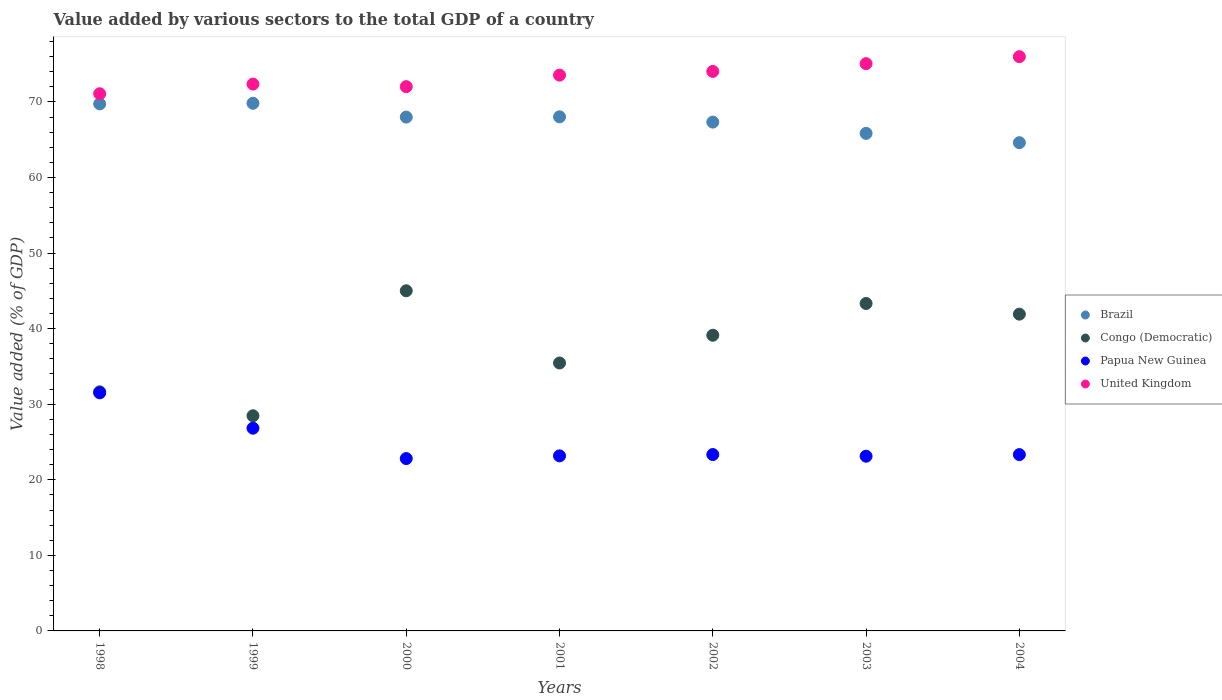How many different coloured dotlines are there?
Your answer should be compact. 4. What is the value added by various sectors to the total GDP in Congo (Democratic) in 1998?
Your response must be concise. 31.64. Across all years, what is the maximum value added by various sectors to the total GDP in Papua New Guinea?
Give a very brief answer. 31.51. Across all years, what is the minimum value added by various sectors to the total GDP in Congo (Democratic)?
Ensure brevity in your answer.  28.47. In which year was the value added by various sectors to the total GDP in United Kingdom maximum?
Give a very brief answer. 2004. In which year was the value added by various sectors to the total GDP in Brazil minimum?
Offer a very short reply. 2004. What is the total value added by various sectors to the total GDP in Brazil in the graph?
Your answer should be compact. 473.39. What is the difference between the value added by various sectors to the total GDP in United Kingdom in 1998 and that in 2002?
Ensure brevity in your answer.  -2.95. What is the difference between the value added by various sectors to the total GDP in Brazil in 2003 and the value added by various sectors to the total GDP in United Kingdom in 2000?
Provide a short and direct response. -6.18. What is the average value added by various sectors to the total GDP in Papua New Guinea per year?
Ensure brevity in your answer.  24.87. In the year 2003, what is the difference between the value added by various sectors to the total GDP in Congo (Democratic) and value added by various sectors to the total GDP in Papua New Guinea?
Keep it short and to the point. 20.21. In how many years, is the value added by various sectors to the total GDP in United Kingdom greater than 60 %?
Make the answer very short. 7. What is the ratio of the value added by various sectors to the total GDP in Congo (Democratic) in 2000 to that in 2004?
Provide a succinct answer. 1.07. Is the value added by various sectors to the total GDP in United Kingdom in 1999 less than that in 2000?
Offer a terse response. No. Is the difference between the value added by various sectors to the total GDP in Congo (Democratic) in 1999 and 2003 greater than the difference between the value added by various sectors to the total GDP in Papua New Guinea in 1999 and 2003?
Your answer should be very brief. No. What is the difference between the highest and the second highest value added by various sectors to the total GDP in Congo (Democratic)?
Give a very brief answer. 1.68. What is the difference between the highest and the lowest value added by various sectors to the total GDP in United Kingdom?
Your answer should be very brief. 4.9. In how many years, is the value added by various sectors to the total GDP in Papua New Guinea greater than the average value added by various sectors to the total GDP in Papua New Guinea taken over all years?
Ensure brevity in your answer.  2. Does the value added by various sectors to the total GDP in Brazil monotonically increase over the years?
Your answer should be very brief. No. How many dotlines are there?
Make the answer very short. 4. What is the difference between two consecutive major ticks on the Y-axis?
Keep it short and to the point. 10. Are the values on the major ticks of Y-axis written in scientific E-notation?
Provide a short and direct response. No. Does the graph contain grids?
Keep it short and to the point. No. What is the title of the graph?
Offer a terse response. Value added by various sectors to the total GDP of a country. What is the label or title of the Y-axis?
Ensure brevity in your answer.  Value added (% of GDP). What is the Value added (% of GDP) of Brazil in 1998?
Your answer should be compact. 69.75. What is the Value added (% of GDP) of Congo (Democratic) in 1998?
Your answer should be very brief. 31.64. What is the Value added (% of GDP) in Papua New Guinea in 1998?
Ensure brevity in your answer.  31.51. What is the Value added (% of GDP) of United Kingdom in 1998?
Provide a succinct answer. 71.09. What is the Value added (% of GDP) of Brazil in 1999?
Give a very brief answer. 69.83. What is the Value added (% of GDP) of Congo (Democratic) in 1999?
Provide a short and direct response. 28.47. What is the Value added (% of GDP) in Papua New Guinea in 1999?
Your response must be concise. 26.83. What is the Value added (% of GDP) of United Kingdom in 1999?
Keep it short and to the point. 72.37. What is the Value added (% of GDP) in Brazil in 2000?
Provide a short and direct response. 68. What is the Value added (% of GDP) in Congo (Democratic) in 2000?
Provide a short and direct response. 45.01. What is the Value added (% of GDP) in Papua New Guinea in 2000?
Your answer should be compact. 22.81. What is the Value added (% of GDP) in United Kingdom in 2000?
Your answer should be very brief. 72.03. What is the Value added (% of GDP) of Brazil in 2001?
Your answer should be compact. 68.03. What is the Value added (% of GDP) in Congo (Democratic) in 2001?
Provide a short and direct response. 35.46. What is the Value added (% of GDP) in Papua New Guinea in 2001?
Provide a succinct answer. 23.17. What is the Value added (% of GDP) of United Kingdom in 2001?
Your response must be concise. 73.55. What is the Value added (% of GDP) in Brazil in 2002?
Offer a terse response. 67.33. What is the Value added (% of GDP) in Congo (Democratic) in 2002?
Make the answer very short. 39.13. What is the Value added (% of GDP) in Papua New Guinea in 2002?
Give a very brief answer. 23.34. What is the Value added (% of GDP) of United Kingdom in 2002?
Give a very brief answer. 74.04. What is the Value added (% of GDP) in Brazil in 2003?
Provide a succinct answer. 65.84. What is the Value added (% of GDP) in Congo (Democratic) in 2003?
Your answer should be very brief. 43.33. What is the Value added (% of GDP) of Papua New Guinea in 2003?
Provide a short and direct response. 23.12. What is the Value added (% of GDP) in United Kingdom in 2003?
Your answer should be very brief. 75.07. What is the Value added (% of GDP) in Brazil in 2004?
Offer a terse response. 64.61. What is the Value added (% of GDP) of Congo (Democratic) in 2004?
Ensure brevity in your answer.  41.92. What is the Value added (% of GDP) of Papua New Guinea in 2004?
Keep it short and to the point. 23.33. What is the Value added (% of GDP) in United Kingdom in 2004?
Give a very brief answer. 75.99. Across all years, what is the maximum Value added (% of GDP) of Brazil?
Keep it short and to the point. 69.83. Across all years, what is the maximum Value added (% of GDP) in Congo (Democratic)?
Your response must be concise. 45.01. Across all years, what is the maximum Value added (% of GDP) of Papua New Guinea?
Ensure brevity in your answer.  31.51. Across all years, what is the maximum Value added (% of GDP) in United Kingdom?
Your answer should be very brief. 75.99. Across all years, what is the minimum Value added (% of GDP) in Brazil?
Your response must be concise. 64.61. Across all years, what is the minimum Value added (% of GDP) of Congo (Democratic)?
Ensure brevity in your answer.  28.47. Across all years, what is the minimum Value added (% of GDP) of Papua New Guinea?
Your answer should be compact. 22.81. Across all years, what is the minimum Value added (% of GDP) of United Kingdom?
Your answer should be compact. 71.09. What is the total Value added (% of GDP) in Brazil in the graph?
Offer a terse response. 473.39. What is the total Value added (% of GDP) in Congo (Democratic) in the graph?
Ensure brevity in your answer.  264.96. What is the total Value added (% of GDP) in Papua New Guinea in the graph?
Provide a short and direct response. 174.11. What is the total Value added (% of GDP) of United Kingdom in the graph?
Your response must be concise. 514.14. What is the difference between the Value added (% of GDP) in Brazil in 1998 and that in 1999?
Ensure brevity in your answer.  -0.08. What is the difference between the Value added (% of GDP) of Congo (Democratic) in 1998 and that in 1999?
Offer a very short reply. 3.17. What is the difference between the Value added (% of GDP) in Papua New Guinea in 1998 and that in 1999?
Your answer should be very brief. 4.68. What is the difference between the Value added (% of GDP) of United Kingdom in 1998 and that in 1999?
Ensure brevity in your answer.  -1.28. What is the difference between the Value added (% of GDP) of Brazil in 1998 and that in 2000?
Offer a terse response. 1.75. What is the difference between the Value added (% of GDP) in Congo (Democratic) in 1998 and that in 2000?
Your answer should be compact. -13.37. What is the difference between the Value added (% of GDP) of Papua New Guinea in 1998 and that in 2000?
Offer a very short reply. 8.7. What is the difference between the Value added (% of GDP) of United Kingdom in 1998 and that in 2000?
Give a very brief answer. -0.94. What is the difference between the Value added (% of GDP) of Brazil in 1998 and that in 2001?
Your answer should be very brief. 1.71. What is the difference between the Value added (% of GDP) of Congo (Democratic) in 1998 and that in 2001?
Offer a very short reply. -3.81. What is the difference between the Value added (% of GDP) in Papua New Guinea in 1998 and that in 2001?
Provide a short and direct response. 8.34. What is the difference between the Value added (% of GDP) in United Kingdom in 1998 and that in 2001?
Your answer should be very brief. -2.46. What is the difference between the Value added (% of GDP) of Brazil in 1998 and that in 2002?
Keep it short and to the point. 2.41. What is the difference between the Value added (% of GDP) of Congo (Democratic) in 1998 and that in 2002?
Your answer should be very brief. -7.49. What is the difference between the Value added (% of GDP) in Papua New Guinea in 1998 and that in 2002?
Give a very brief answer. 8.17. What is the difference between the Value added (% of GDP) of United Kingdom in 1998 and that in 2002?
Ensure brevity in your answer.  -2.95. What is the difference between the Value added (% of GDP) in Brazil in 1998 and that in 2003?
Your response must be concise. 3.9. What is the difference between the Value added (% of GDP) in Congo (Democratic) in 1998 and that in 2003?
Keep it short and to the point. -11.69. What is the difference between the Value added (% of GDP) in Papua New Guinea in 1998 and that in 2003?
Your answer should be compact. 8.39. What is the difference between the Value added (% of GDP) in United Kingdom in 1998 and that in 2003?
Ensure brevity in your answer.  -3.98. What is the difference between the Value added (% of GDP) in Brazil in 1998 and that in 2004?
Provide a short and direct response. 5.13. What is the difference between the Value added (% of GDP) of Congo (Democratic) in 1998 and that in 2004?
Make the answer very short. -10.28. What is the difference between the Value added (% of GDP) in Papua New Guinea in 1998 and that in 2004?
Your answer should be compact. 8.18. What is the difference between the Value added (% of GDP) in United Kingdom in 1998 and that in 2004?
Ensure brevity in your answer.  -4.9. What is the difference between the Value added (% of GDP) in Brazil in 1999 and that in 2000?
Your answer should be very brief. 1.83. What is the difference between the Value added (% of GDP) of Congo (Democratic) in 1999 and that in 2000?
Your answer should be compact. -16.54. What is the difference between the Value added (% of GDP) of Papua New Guinea in 1999 and that in 2000?
Offer a terse response. 4.02. What is the difference between the Value added (% of GDP) in United Kingdom in 1999 and that in 2000?
Provide a succinct answer. 0.34. What is the difference between the Value added (% of GDP) in Brazil in 1999 and that in 2001?
Offer a terse response. 1.79. What is the difference between the Value added (% of GDP) in Congo (Democratic) in 1999 and that in 2001?
Make the answer very short. -6.98. What is the difference between the Value added (% of GDP) in Papua New Guinea in 1999 and that in 2001?
Make the answer very short. 3.66. What is the difference between the Value added (% of GDP) in United Kingdom in 1999 and that in 2001?
Your answer should be very brief. -1.19. What is the difference between the Value added (% of GDP) in Brazil in 1999 and that in 2002?
Offer a terse response. 2.49. What is the difference between the Value added (% of GDP) of Congo (Democratic) in 1999 and that in 2002?
Give a very brief answer. -10.65. What is the difference between the Value added (% of GDP) of Papua New Guinea in 1999 and that in 2002?
Your response must be concise. 3.49. What is the difference between the Value added (% of GDP) in United Kingdom in 1999 and that in 2002?
Offer a terse response. -1.67. What is the difference between the Value added (% of GDP) of Brazil in 1999 and that in 2003?
Give a very brief answer. 3.98. What is the difference between the Value added (% of GDP) of Congo (Democratic) in 1999 and that in 2003?
Ensure brevity in your answer.  -14.86. What is the difference between the Value added (% of GDP) of Papua New Guinea in 1999 and that in 2003?
Your answer should be very brief. 3.71. What is the difference between the Value added (% of GDP) of United Kingdom in 1999 and that in 2003?
Provide a succinct answer. -2.7. What is the difference between the Value added (% of GDP) in Brazil in 1999 and that in 2004?
Provide a short and direct response. 5.22. What is the difference between the Value added (% of GDP) in Congo (Democratic) in 1999 and that in 2004?
Your response must be concise. -13.45. What is the difference between the Value added (% of GDP) of Papua New Guinea in 1999 and that in 2004?
Offer a terse response. 3.5. What is the difference between the Value added (% of GDP) in United Kingdom in 1999 and that in 2004?
Your answer should be very brief. -3.63. What is the difference between the Value added (% of GDP) in Brazil in 2000 and that in 2001?
Offer a terse response. -0.04. What is the difference between the Value added (% of GDP) of Congo (Democratic) in 2000 and that in 2001?
Keep it short and to the point. 9.56. What is the difference between the Value added (% of GDP) in Papua New Guinea in 2000 and that in 2001?
Provide a succinct answer. -0.36. What is the difference between the Value added (% of GDP) in United Kingdom in 2000 and that in 2001?
Ensure brevity in your answer.  -1.53. What is the difference between the Value added (% of GDP) in Brazil in 2000 and that in 2002?
Provide a succinct answer. 0.66. What is the difference between the Value added (% of GDP) in Congo (Democratic) in 2000 and that in 2002?
Provide a succinct answer. 5.89. What is the difference between the Value added (% of GDP) of Papua New Guinea in 2000 and that in 2002?
Give a very brief answer. -0.53. What is the difference between the Value added (% of GDP) of United Kingdom in 2000 and that in 2002?
Your response must be concise. -2.01. What is the difference between the Value added (% of GDP) in Brazil in 2000 and that in 2003?
Keep it short and to the point. 2.15. What is the difference between the Value added (% of GDP) of Congo (Democratic) in 2000 and that in 2003?
Your answer should be compact. 1.68. What is the difference between the Value added (% of GDP) in Papua New Guinea in 2000 and that in 2003?
Ensure brevity in your answer.  -0.31. What is the difference between the Value added (% of GDP) in United Kingdom in 2000 and that in 2003?
Ensure brevity in your answer.  -3.04. What is the difference between the Value added (% of GDP) in Brazil in 2000 and that in 2004?
Offer a terse response. 3.39. What is the difference between the Value added (% of GDP) of Congo (Democratic) in 2000 and that in 2004?
Offer a very short reply. 3.09. What is the difference between the Value added (% of GDP) in Papua New Guinea in 2000 and that in 2004?
Give a very brief answer. -0.53. What is the difference between the Value added (% of GDP) in United Kingdom in 2000 and that in 2004?
Provide a short and direct response. -3.97. What is the difference between the Value added (% of GDP) in Brazil in 2001 and that in 2002?
Offer a terse response. 0.7. What is the difference between the Value added (% of GDP) in Congo (Democratic) in 2001 and that in 2002?
Keep it short and to the point. -3.67. What is the difference between the Value added (% of GDP) in Papua New Guinea in 2001 and that in 2002?
Your answer should be compact. -0.17. What is the difference between the Value added (% of GDP) in United Kingdom in 2001 and that in 2002?
Offer a very short reply. -0.49. What is the difference between the Value added (% of GDP) in Brazil in 2001 and that in 2003?
Offer a terse response. 2.19. What is the difference between the Value added (% of GDP) of Congo (Democratic) in 2001 and that in 2003?
Provide a succinct answer. -7.88. What is the difference between the Value added (% of GDP) of Papua New Guinea in 2001 and that in 2003?
Make the answer very short. 0.05. What is the difference between the Value added (% of GDP) of United Kingdom in 2001 and that in 2003?
Provide a short and direct response. -1.52. What is the difference between the Value added (% of GDP) of Brazil in 2001 and that in 2004?
Ensure brevity in your answer.  3.42. What is the difference between the Value added (% of GDP) of Congo (Democratic) in 2001 and that in 2004?
Offer a very short reply. -6.46. What is the difference between the Value added (% of GDP) of Papua New Guinea in 2001 and that in 2004?
Give a very brief answer. -0.17. What is the difference between the Value added (% of GDP) of United Kingdom in 2001 and that in 2004?
Provide a short and direct response. -2.44. What is the difference between the Value added (% of GDP) of Brazil in 2002 and that in 2003?
Provide a short and direct response. 1.49. What is the difference between the Value added (% of GDP) in Congo (Democratic) in 2002 and that in 2003?
Provide a short and direct response. -4.21. What is the difference between the Value added (% of GDP) of Papua New Guinea in 2002 and that in 2003?
Your answer should be compact. 0.22. What is the difference between the Value added (% of GDP) of United Kingdom in 2002 and that in 2003?
Provide a short and direct response. -1.03. What is the difference between the Value added (% of GDP) in Brazil in 2002 and that in 2004?
Provide a short and direct response. 2.72. What is the difference between the Value added (% of GDP) of Congo (Democratic) in 2002 and that in 2004?
Offer a very short reply. -2.79. What is the difference between the Value added (% of GDP) of Papua New Guinea in 2002 and that in 2004?
Offer a very short reply. 0.01. What is the difference between the Value added (% of GDP) in United Kingdom in 2002 and that in 2004?
Offer a terse response. -1.95. What is the difference between the Value added (% of GDP) of Brazil in 2003 and that in 2004?
Ensure brevity in your answer.  1.23. What is the difference between the Value added (% of GDP) in Congo (Democratic) in 2003 and that in 2004?
Your response must be concise. 1.41. What is the difference between the Value added (% of GDP) in Papua New Guinea in 2003 and that in 2004?
Ensure brevity in your answer.  -0.21. What is the difference between the Value added (% of GDP) of United Kingdom in 2003 and that in 2004?
Offer a very short reply. -0.92. What is the difference between the Value added (% of GDP) in Brazil in 1998 and the Value added (% of GDP) in Congo (Democratic) in 1999?
Your response must be concise. 41.27. What is the difference between the Value added (% of GDP) of Brazil in 1998 and the Value added (% of GDP) of Papua New Guinea in 1999?
Your answer should be compact. 42.92. What is the difference between the Value added (% of GDP) in Brazil in 1998 and the Value added (% of GDP) in United Kingdom in 1999?
Provide a short and direct response. -2.62. What is the difference between the Value added (% of GDP) of Congo (Democratic) in 1998 and the Value added (% of GDP) of Papua New Guinea in 1999?
Provide a succinct answer. 4.81. What is the difference between the Value added (% of GDP) in Congo (Democratic) in 1998 and the Value added (% of GDP) in United Kingdom in 1999?
Provide a short and direct response. -40.73. What is the difference between the Value added (% of GDP) in Papua New Guinea in 1998 and the Value added (% of GDP) in United Kingdom in 1999?
Make the answer very short. -40.86. What is the difference between the Value added (% of GDP) of Brazil in 1998 and the Value added (% of GDP) of Congo (Democratic) in 2000?
Provide a succinct answer. 24.73. What is the difference between the Value added (% of GDP) of Brazil in 1998 and the Value added (% of GDP) of Papua New Guinea in 2000?
Your answer should be compact. 46.94. What is the difference between the Value added (% of GDP) in Brazil in 1998 and the Value added (% of GDP) in United Kingdom in 2000?
Your response must be concise. -2.28. What is the difference between the Value added (% of GDP) of Congo (Democratic) in 1998 and the Value added (% of GDP) of Papua New Guinea in 2000?
Give a very brief answer. 8.83. What is the difference between the Value added (% of GDP) of Congo (Democratic) in 1998 and the Value added (% of GDP) of United Kingdom in 2000?
Give a very brief answer. -40.39. What is the difference between the Value added (% of GDP) of Papua New Guinea in 1998 and the Value added (% of GDP) of United Kingdom in 2000?
Give a very brief answer. -40.52. What is the difference between the Value added (% of GDP) in Brazil in 1998 and the Value added (% of GDP) in Congo (Democratic) in 2001?
Provide a short and direct response. 34.29. What is the difference between the Value added (% of GDP) in Brazil in 1998 and the Value added (% of GDP) in Papua New Guinea in 2001?
Give a very brief answer. 46.58. What is the difference between the Value added (% of GDP) of Brazil in 1998 and the Value added (% of GDP) of United Kingdom in 2001?
Your response must be concise. -3.81. What is the difference between the Value added (% of GDP) in Congo (Democratic) in 1998 and the Value added (% of GDP) in Papua New Guinea in 2001?
Offer a very short reply. 8.47. What is the difference between the Value added (% of GDP) of Congo (Democratic) in 1998 and the Value added (% of GDP) of United Kingdom in 2001?
Your response must be concise. -41.91. What is the difference between the Value added (% of GDP) of Papua New Guinea in 1998 and the Value added (% of GDP) of United Kingdom in 2001?
Your answer should be very brief. -42.04. What is the difference between the Value added (% of GDP) in Brazil in 1998 and the Value added (% of GDP) in Congo (Democratic) in 2002?
Your answer should be very brief. 30.62. What is the difference between the Value added (% of GDP) of Brazil in 1998 and the Value added (% of GDP) of Papua New Guinea in 2002?
Give a very brief answer. 46.4. What is the difference between the Value added (% of GDP) in Brazil in 1998 and the Value added (% of GDP) in United Kingdom in 2002?
Your response must be concise. -4.29. What is the difference between the Value added (% of GDP) in Congo (Democratic) in 1998 and the Value added (% of GDP) in Papua New Guinea in 2002?
Provide a short and direct response. 8.3. What is the difference between the Value added (% of GDP) of Congo (Democratic) in 1998 and the Value added (% of GDP) of United Kingdom in 2002?
Ensure brevity in your answer.  -42.4. What is the difference between the Value added (% of GDP) in Papua New Guinea in 1998 and the Value added (% of GDP) in United Kingdom in 2002?
Your answer should be compact. -42.53. What is the difference between the Value added (% of GDP) in Brazil in 1998 and the Value added (% of GDP) in Congo (Democratic) in 2003?
Offer a very short reply. 26.41. What is the difference between the Value added (% of GDP) in Brazil in 1998 and the Value added (% of GDP) in Papua New Guinea in 2003?
Offer a very short reply. 46.63. What is the difference between the Value added (% of GDP) of Brazil in 1998 and the Value added (% of GDP) of United Kingdom in 2003?
Offer a terse response. -5.32. What is the difference between the Value added (% of GDP) in Congo (Democratic) in 1998 and the Value added (% of GDP) in Papua New Guinea in 2003?
Your response must be concise. 8.52. What is the difference between the Value added (% of GDP) in Congo (Democratic) in 1998 and the Value added (% of GDP) in United Kingdom in 2003?
Give a very brief answer. -43.43. What is the difference between the Value added (% of GDP) of Papua New Guinea in 1998 and the Value added (% of GDP) of United Kingdom in 2003?
Provide a short and direct response. -43.56. What is the difference between the Value added (% of GDP) in Brazil in 1998 and the Value added (% of GDP) in Congo (Democratic) in 2004?
Give a very brief answer. 27.83. What is the difference between the Value added (% of GDP) in Brazil in 1998 and the Value added (% of GDP) in Papua New Guinea in 2004?
Offer a terse response. 46.41. What is the difference between the Value added (% of GDP) in Brazil in 1998 and the Value added (% of GDP) in United Kingdom in 2004?
Provide a short and direct response. -6.25. What is the difference between the Value added (% of GDP) of Congo (Democratic) in 1998 and the Value added (% of GDP) of Papua New Guinea in 2004?
Offer a very short reply. 8.31. What is the difference between the Value added (% of GDP) of Congo (Democratic) in 1998 and the Value added (% of GDP) of United Kingdom in 2004?
Provide a short and direct response. -44.35. What is the difference between the Value added (% of GDP) of Papua New Guinea in 1998 and the Value added (% of GDP) of United Kingdom in 2004?
Offer a very short reply. -44.48. What is the difference between the Value added (% of GDP) of Brazil in 1999 and the Value added (% of GDP) of Congo (Democratic) in 2000?
Give a very brief answer. 24.81. What is the difference between the Value added (% of GDP) of Brazil in 1999 and the Value added (% of GDP) of Papua New Guinea in 2000?
Give a very brief answer. 47.02. What is the difference between the Value added (% of GDP) of Brazil in 1999 and the Value added (% of GDP) of United Kingdom in 2000?
Your answer should be compact. -2.2. What is the difference between the Value added (% of GDP) in Congo (Democratic) in 1999 and the Value added (% of GDP) in Papua New Guinea in 2000?
Your response must be concise. 5.66. What is the difference between the Value added (% of GDP) of Congo (Democratic) in 1999 and the Value added (% of GDP) of United Kingdom in 2000?
Provide a short and direct response. -43.55. What is the difference between the Value added (% of GDP) in Papua New Guinea in 1999 and the Value added (% of GDP) in United Kingdom in 2000?
Ensure brevity in your answer.  -45.2. What is the difference between the Value added (% of GDP) of Brazil in 1999 and the Value added (% of GDP) of Congo (Democratic) in 2001?
Your response must be concise. 34.37. What is the difference between the Value added (% of GDP) of Brazil in 1999 and the Value added (% of GDP) of Papua New Guinea in 2001?
Provide a short and direct response. 46.66. What is the difference between the Value added (% of GDP) of Brazil in 1999 and the Value added (% of GDP) of United Kingdom in 2001?
Give a very brief answer. -3.73. What is the difference between the Value added (% of GDP) in Congo (Democratic) in 1999 and the Value added (% of GDP) in Papua New Guinea in 2001?
Your answer should be very brief. 5.31. What is the difference between the Value added (% of GDP) in Congo (Democratic) in 1999 and the Value added (% of GDP) in United Kingdom in 2001?
Provide a short and direct response. -45.08. What is the difference between the Value added (% of GDP) of Papua New Guinea in 1999 and the Value added (% of GDP) of United Kingdom in 2001?
Ensure brevity in your answer.  -46.72. What is the difference between the Value added (% of GDP) in Brazil in 1999 and the Value added (% of GDP) in Congo (Democratic) in 2002?
Your response must be concise. 30.7. What is the difference between the Value added (% of GDP) in Brazil in 1999 and the Value added (% of GDP) in Papua New Guinea in 2002?
Your response must be concise. 46.48. What is the difference between the Value added (% of GDP) of Brazil in 1999 and the Value added (% of GDP) of United Kingdom in 2002?
Ensure brevity in your answer.  -4.21. What is the difference between the Value added (% of GDP) of Congo (Democratic) in 1999 and the Value added (% of GDP) of Papua New Guinea in 2002?
Your answer should be compact. 5.13. What is the difference between the Value added (% of GDP) of Congo (Democratic) in 1999 and the Value added (% of GDP) of United Kingdom in 2002?
Your answer should be compact. -45.57. What is the difference between the Value added (% of GDP) in Papua New Guinea in 1999 and the Value added (% of GDP) in United Kingdom in 2002?
Ensure brevity in your answer.  -47.21. What is the difference between the Value added (% of GDP) of Brazil in 1999 and the Value added (% of GDP) of Congo (Democratic) in 2003?
Provide a succinct answer. 26.49. What is the difference between the Value added (% of GDP) in Brazil in 1999 and the Value added (% of GDP) in Papua New Guinea in 2003?
Offer a very short reply. 46.71. What is the difference between the Value added (% of GDP) of Brazil in 1999 and the Value added (% of GDP) of United Kingdom in 2003?
Your answer should be compact. -5.24. What is the difference between the Value added (% of GDP) in Congo (Democratic) in 1999 and the Value added (% of GDP) in Papua New Guinea in 2003?
Provide a succinct answer. 5.35. What is the difference between the Value added (% of GDP) of Congo (Democratic) in 1999 and the Value added (% of GDP) of United Kingdom in 2003?
Ensure brevity in your answer.  -46.6. What is the difference between the Value added (% of GDP) of Papua New Guinea in 1999 and the Value added (% of GDP) of United Kingdom in 2003?
Keep it short and to the point. -48.24. What is the difference between the Value added (% of GDP) in Brazil in 1999 and the Value added (% of GDP) in Congo (Democratic) in 2004?
Offer a very short reply. 27.91. What is the difference between the Value added (% of GDP) of Brazil in 1999 and the Value added (% of GDP) of Papua New Guinea in 2004?
Provide a succinct answer. 46.49. What is the difference between the Value added (% of GDP) in Brazil in 1999 and the Value added (% of GDP) in United Kingdom in 2004?
Keep it short and to the point. -6.17. What is the difference between the Value added (% of GDP) of Congo (Democratic) in 1999 and the Value added (% of GDP) of Papua New Guinea in 2004?
Offer a very short reply. 5.14. What is the difference between the Value added (% of GDP) of Congo (Democratic) in 1999 and the Value added (% of GDP) of United Kingdom in 2004?
Offer a very short reply. -47.52. What is the difference between the Value added (% of GDP) in Papua New Guinea in 1999 and the Value added (% of GDP) in United Kingdom in 2004?
Ensure brevity in your answer.  -49.16. What is the difference between the Value added (% of GDP) of Brazil in 2000 and the Value added (% of GDP) of Congo (Democratic) in 2001?
Keep it short and to the point. 32.54. What is the difference between the Value added (% of GDP) in Brazil in 2000 and the Value added (% of GDP) in Papua New Guinea in 2001?
Ensure brevity in your answer.  44.83. What is the difference between the Value added (% of GDP) in Brazil in 2000 and the Value added (% of GDP) in United Kingdom in 2001?
Your answer should be compact. -5.56. What is the difference between the Value added (% of GDP) in Congo (Democratic) in 2000 and the Value added (% of GDP) in Papua New Guinea in 2001?
Provide a short and direct response. 21.85. What is the difference between the Value added (% of GDP) of Congo (Democratic) in 2000 and the Value added (% of GDP) of United Kingdom in 2001?
Offer a very short reply. -28.54. What is the difference between the Value added (% of GDP) of Papua New Guinea in 2000 and the Value added (% of GDP) of United Kingdom in 2001?
Give a very brief answer. -50.74. What is the difference between the Value added (% of GDP) in Brazil in 2000 and the Value added (% of GDP) in Congo (Democratic) in 2002?
Provide a succinct answer. 28.87. What is the difference between the Value added (% of GDP) in Brazil in 2000 and the Value added (% of GDP) in Papua New Guinea in 2002?
Keep it short and to the point. 44.66. What is the difference between the Value added (% of GDP) in Brazil in 2000 and the Value added (% of GDP) in United Kingdom in 2002?
Your answer should be very brief. -6.04. What is the difference between the Value added (% of GDP) of Congo (Democratic) in 2000 and the Value added (% of GDP) of Papua New Guinea in 2002?
Keep it short and to the point. 21.67. What is the difference between the Value added (% of GDP) of Congo (Democratic) in 2000 and the Value added (% of GDP) of United Kingdom in 2002?
Offer a terse response. -29.03. What is the difference between the Value added (% of GDP) of Papua New Guinea in 2000 and the Value added (% of GDP) of United Kingdom in 2002?
Offer a terse response. -51.23. What is the difference between the Value added (% of GDP) of Brazil in 2000 and the Value added (% of GDP) of Congo (Democratic) in 2003?
Keep it short and to the point. 24.66. What is the difference between the Value added (% of GDP) of Brazil in 2000 and the Value added (% of GDP) of Papua New Guinea in 2003?
Make the answer very short. 44.88. What is the difference between the Value added (% of GDP) of Brazil in 2000 and the Value added (% of GDP) of United Kingdom in 2003?
Offer a terse response. -7.07. What is the difference between the Value added (% of GDP) of Congo (Democratic) in 2000 and the Value added (% of GDP) of Papua New Guinea in 2003?
Make the answer very short. 21.89. What is the difference between the Value added (% of GDP) in Congo (Democratic) in 2000 and the Value added (% of GDP) in United Kingdom in 2003?
Your answer should be compact. -30.06. What is the difference between the Value added (% of GDP) in Papua New Guinea in 2000 and the Value added (% of GDP) in United Kingdom in 2003?
Provide a succinct answer. -52.26. What is the difference between the Value added (% of GDP) of Brazil in 2000 and the Value added (% of GDP) of Congo (Democratic) in 2004?
Keep it short and to the point. 26.08. What is the difference between the Value added (% of GDP) of Brazil in 2000 and the Value added (% of GDP) of Papua New Guinea in 2004?
Your response must be concise. 44.66. What is the difference between the Value added (% of GDP) in Brazil in 2000 and the Value added (% of GDP) in United Kingdom in 2004?
Ensure brevity in your answer.  -8. What is the difference between the Value added (% of GDP) of Congo (Democratic) in 2000 and the Value added (% of GDP) of Papua New Guinea in 2004?
Keep it short and to the point. 21.68. What is the difference between the Value added (% of GDP) of Congo (Democratic) in 2000 and the Value added (% of GDP) of United Kingdom in 2004?
Your response must be concise. -30.98. What is the difference between the Value added (% of GDP) in Papua New Guinea in 2000 and the Value added (% of GDP) in United Kingdom in 2004?
Ensure brevity in your answer.  -53.18. What is the difference between the Value added (% of GDP) in Brazil in 2001 and the Value added (% of GDP) in Congo (Democratic) in 2002?
Make the answer very short. 28.91. What is the difference between the Value added (% of GDP) of Brazil in 2001 and the Value added (% of GDP) of Papua New Guinea in 2002?
Make the answer very short. 44.69. What is the difference between the Value added (% of GDP) in Brazil in 2001 and the Value added (% of GDP) in United Kingdom in 2002?
Keep it short and to the point. -6.01. What is the difference between the Value added (% of GDP) in Congo (Democratic) in 2001 and the Value added (% of GDP) in Papua New Guinea in 2002?
Provide a succinct answer. 12.11. What is the difference between the Value added (% of GDP) of Congo (Democratic) in 2001 and the Value added (% of GDP) of United Kingdom in 2002?
Provide a succinct answer. -38.58. What is the difference between the Value added (% of GDP) of Papua New Guinea in 2001 and the Value added (% of GDP) of United Kingdom in 2002?
Make the answer very short. -50.87. What is the difference between the Value added (% of GDP) in Brazil in 2001 and the Value added (% of GDP) in Congo (Democratic) in 2003?
Ensure brevity in your answer.  24.7. What is the difference between the Value added (% of GDP) of Brazil in 2001 and the Value added (% of GDP) of Papua New Guinea in 2003?
Your response must be concise. 44.91. What is the difference between the Value added (% of GDP) of Brazil in 2001 and the Value added (% of GDP) of United Kingdom in 2003?
Provide a succinct answer. -7.04. What is the difference between the Value added (% of GDP) of Congo (Democratic) in 2001 and the Value added (% of GDP) of Papua New Guinea in 2003?
Provide a short and direct response. 12.34. What is the difference between the Value added (% of GDP) in Congo (Democratic) in 2001 and the Value added (% of GDP) in United Kingdom in 2003?
Offer a very short reply. -39.61. What is the difference between the Value added (% of GDP) of Papua New Guinea in 2001 and the Value added (% of GDP) of United Kingdom in 2003?
Ensure brevity in your answer.  -51.9. What is the difference between the Value added (% of GDP) in Brazil in 2001 and the Value added (% of GDP) in Congo (Democratic) in 2004?
Make the answer very short. 26.11. What is the difference between the Value added (% of GDP) of Brazil in 2001 and the Value added (% of GDP) of Papua New Guinea in 2004?
Give a very brief answer. 44.7. What is the difference between the Value added (% of GDP) of Brazil in 2001 and the Value added (% of GDP) of United Kingdom in 2004?
Ensure brevity in your answer.  -7.96. What is the difference between the Value added (% of GDP) of Congo (Democratic) in 2001 and the Value added (% of GDP) of Papua New Guinea in 2004?
Provide a succinct answer. 12.12. What is the difference between the Value added (% of GDP) in Congo (Democratic) in 2001 and the Value added (% of GDP) in United Kingdom in 2004?
Provide a short and direct response. -40.54. What is the difference between the Value added (% of GDP) of Papua New Guinea in 2001 and the Value added (% of GDP) of United Kingdom in 2004?
Give a very brief answer. -52.83. What is the difference between the Value added (% of GDP) in Brazil in 2002 and the Value added (% of GDP) in Congo (Democratic) in 2003?
Make the answer very short. 24. What is the difference between the Value added (% of GDP) in Brazil in 2002 and the Value added (% of GDP) in Papua New Guinea in 2003?
Make the answer very short. 44.21. What is the difference between the Value added (% of GDP) in Brazil in 2002 and the Value added (% of GDP) in United Kingdom in 2003?
Provide a succinct answer. -7.74. What is the difference between the Value added (% of GDP) of Congo (Democratic) in 2002 and the Value added (% of GDP) of Papua New Guinea in 2003?
Offer a terse response. 16.01. What is the difference between the Value added (% of GDP) in Congo (Democratic) in 2002 and the Value added (% of GDP) in United Kingdom in 2003?
Your answer should be very brief. -35.94. What is the difference between the Value added (% of GDP) of Papua New Guinea in 2002 and the Value added (% of GDP) of United Kingdom in 2003?
Keep it short and to the point. -51.73. What is the difference between the Value added (% of GDP) of Brazil in 2002 and the Value added (% of GDP) of Congo (Democratic) in 2004?
Offer a very short reply. 25.41. What is the difference between the Value added (% of GDP) of Brazil in 2002 and the Value added (% of GDP) of Papua New Guinea in 2004?
Offer a very short reply. 44. What is the difference between the Value added (% of GDP) of Brazil in 2002 and the Value added (% of GDP) of United Kingdom in 2004?
Provide a short and direct response. -8.66. What is the difference between the Value added (% of GDP) in Congo (Democratic) in 2002 and the Value added (% of GDP) in Papua New Guinea in 2004?
Your response must be concise. 15.79. What is the difference between the Value added (% of GDP) in Congo (Democratic) in 2002 and the Value added (% of GDP) in United Kingdom in 2004?
Provide a succinct answer. -36.87. What is the difference between the Value added (% of GDP) in Papua New Guinea in 2002 and the Value added (% of GDP) in United Kingdom in 2004?
Provide a short and direct response. -52.65. What is the difference between the Value added (% of GDP) of Brazil in 2003 and the Value added (% of GDP) of Congo (Democratic) in 2004?
Offer a terse response. 23.93. What is the difference between the Value added (% of GDP) of Brazil in 2003 and the Value added (% of GDP) of Papua New Guinea in 2004?
Give a very brief answer. 42.51. What is the difference between the Value added (% of GDP) in Brazil in 2003 and the Value added (% of GDP) in United Kingdom in 2004?
Give a very brief answer. -10.15. What is the difference between the Value added (% of GDP) of Congo (Democratic) in 2003 and the Value added (% of GDP) of Papua New Guinea in 2004?
Offer a very short reply. 20. What is the difference between the Value added (% of GDP) of Congo (Democratic) in 2003 and the Value added (% of GDP) of United Kingdom in 2004?
Give a very brief answer. -32.66. What is the difference between the Value added (% of GDP) in Papua New Guinea in 2003 and the Value added (% of GDP) in United Kingdom in 2004?
Offer a terse response. -52.87. What is the average Value added (% of GDP) in Brazil per year?
Ensure brevity in your answer.  67.63. What is the average Value added (% of GDP) in Congo (Democratic) per year?
Offer a terse response. 37.85. What is the average Value added (% of GDP) in Papua New Guinea per year?
Ensure brevity in your answer.  24.87. What is the average Value added (% of GDP) in United Kingdom per year?
Provide a short and direct response. 73.45. In the year 1998, what is the difference between the Value added (% of GDP) of Brazil and Value added (% of GDP) of Congo (Democratic)?
Keep it short and to the point. 38.1. In the year 1998, what is the difference between the Value added (% of GDP) of Brazil and Value added (% of GDP) of Papua New Guinea?
Provide a short and direct response. 38.23. In the year 1998, what is the difference between the Value added (% of GDP) in Brazil and Value added (% of GDP) in United Kingdom?
Your answer should be compact. -1.34. In the year 1998, what is the difference between the Value added (% of GDP) of Congo (Democratic) and Value added (% of GDP) of Papua New Guinea?
Provide a succinct answer. 0.13. In the year 1998, what is the difference between the Value added (% of GDP) of Congo (Democratic) and Value added (% of GDP) of United Kingdom?
Your answer should be very brief. -39.45. In the year 1998, what is the difference between the Value added (% of GDP) of Papua New Guinea and Value added (% of GDP) of United Kingdom?
Your answer should be very brief. -39.58. In the year 1999, what is the difference between the Value added (% of GDP) of Brazil and Value added (% of GDP) of Congo (Democratic)?
Keep it short and to the point. 41.35. In the year 1999, what is the difference between the Value added (% of GDP) of Brazil and Value added (% of GDP) of Papua New Guinea?
Your answer should be compact. 43. In the year 1999, what is the difference between the Value added (% of GDP) of Brazil and Value added (% of GDP) of United Kingdom?
Your answer should be very brief. -2.54. In the year 1999, what is the difference between the Value added (% of GDP) in Congo (Democratic) and Value added (% of GDP) in Papua New Guinea?
Provide a short and direct response. 1.64. In the year 1999, what is the difference between the Value added (% of GDP) in Congo (Democratic) and Value added (% of GDP) in United Kingdom?
Offer a very short reply. -43.89. In the year 1999, what is the difference between the Value added (% of GDP) in Papua New Guinea and Value added (% of GDP) in United Kingdom?
Keep it short and to the point. -45.54. In the year 2000, what is the difference between the Value added (% of GDP) of Brazil and Value added (% of GDP) of Congo (Democratic)?
Give a very brief answer. 22.98. In the year 2000, what is the difference between the Value added (% of GDP) in Brazil and Value added (% of GDP) in Papua New Guinea?
Your answer should be very brief. 45.19. In the year 2000, what is the difference between the Value added (% of GDP) in Brazil and Value added (% of GDP) in United Kingdom?
Your response must be concise. -4.03. In the year 2000, what is the difference between the Value added (% of GDP) in Congo (Democratic) and Value added (% of GDP) in Papua New Guinea?
Offer a terse response. 22.2. In the year 2000, what is the difference between the Value added (% of GDP) in Congo (Democratic) and Value added (% of GDP) in United Kingdom?
Provide a succinct answer. -27.01. In the year 2000, what is the difference between the Value added (% of GDP) of Papua New Guinea and Value added (% of GDP) of United Kingdom?
Your answer should be compact. -49.22. In the year 2001, what is the difference between the Value added (% of GDP) in Brazil and Value added (% of GDP) in Congo (Democratic)?
Your response must be concise. 32.58. In the year 2001, what is the difference between the Value added (% of GDP) of Brazil and Value added (% of GDP) of Papua New Guinea?
Offer a terse response. 44.87. In the year 2001, what is the difference between the Value added (% of GDP) of Brazil and Value added (% of GDP) of United Kingdom?
Ensure brevity in your answer.  -5.52. In the year 2001, what is the difference between the Value added (% of GDP) of Congo (Democratic) and Value added (% of GDP) of Papua New Guinea?
Your response must be concise. 12.29. In the year 2001, what is the difference between the Value added (% of GDP) of Congo (Democratic) and Value added (% of GDP) of United Kingdom?
Give a very brief answer. -38.1. In the year 2001, what is the difference between the Value added (% of GDP) in Papua New Guinea and Value added (% of GDP) in United Kingdom?
Your response must be concise. -50.39. In the year 2002, what is the difference between the Value added (% of GDP) in Brazil and Value added (% of GDP) in Congo (Democratic)?
Give a very brief answer. 28.21. In the year 2002, what is the difference between the Value added (% of GDP) of Brazil and Value added (% of GDP) of Papua New Guinea?
Your answer should be compact. 43.99. In the year 2002, what is the difference between the Value added (% of GDP) in Brazil and Value added (% of GDP) in United Kingdom?
Offer a terse response. -6.7. In the year 2002, what is the difference between the Value added (% of GDP) of Congo (Democratic) and Value added (% of GDP) of Papua New Guinea?
Ensure brevity in your answer.  15.78. In the year 2002, what is the difference between the Value added (% of GDP) in Congo (Democratic) and Value added (% of GDP) in United Kingdom?
Offer a very short reply. -34.91. In the year 2002, what is the difference between the Value added (% of GDP) in Papua New Guinea and Value added (% of GDP) in United Kingdom?
Offer a very short reply. -50.7. In the year 2003, what is the difference between the Value added (% of GDP) in Brazil and Value added (% of GDP) in Congo (Democratic)?
Ensure brevity in your answer.  22.51. In the year 2003, what is the difference between the Value added (% of GDP) in Brazil and Value added (% of GDP) in Papua New Guinea?
Provide a succinct answer. 42.72. In the year 2003, what is the difference between the Value added (% of GDP) of Brazil and Value added (% of GDP) of United Kingdom?
Offer a very short reply. -9.23. In the year 2003, what is the difference between the Value added (% of GDP) of Congo (Democratic) and Value added (% of GDP) of Papua New Guinea?
Your answer should be very brief. 20.21. In the year 2003, what is the difference between the Value added (% of GDP) of Congo (Democratic) and Value added (% of GDP) of United Kingdom?
Offer a terse response. -31.74. In the year 2003, what is the difference between the Value added (% of GDP) in Papua New Guinea and Value added (% of GDP) in United Kingdom?
Provide a succinct answer. -51.95. In the year 2004, what is the difference between the Value added (% of GDP) in Brazil and Value added (% of GDP) in Congo (Democratic)?
Give a very brief answer. 22.69. In the year 2004, what is the difference between the Value added (% of GDP) of Brazil and Value added (% of GDP) of Papua New Guinea?
Ensure brevity in your answer.  41.28. In the year 2004, what is the difference between the Value added (% of GDP) in Brazil and Value added (% of GDP) in United Kingdom?
Offer a terse response. -11.38. In the year 2004, what is the difference between the Value added (% of GDP) of Congo (Democratic) and Value added (% of GDP) of Papua New Guinea?
Provide a succinct answer. 18.59. In the year 2004, what is the difference between the Value added (% of GDP) of Congo (Democratic) and Value added (% of GDP) of United Kingdom?
Your answer should be very brief. -34.07. In the year 2004, what is the difference between the Value added (% of GDP) in Papua New Guinea and Value added (% of GDP) in United Kingdom?
Provide a succinct answer. -52.66. What is the ratio of the Value added (% of GDP) of Brazil in 1998 to that in 1999?
Offer a very short reply. 1. What is the ratio of the Value added (% of GDP) in Congo (Democratic) in 1998 to that in 1999?
Offer a terse response. 1.11. What is the ratio of the Value added (% of GDP) of Papua New Guinea in 1998 to that in 1999?
Make the answer very short. 1.17. What is the ratio of the Value added (% of GDP) in United Kingdom in 1998 to that in 1999?
Your response must be concise. 0.98. What is the ratio of the Value added (% of GDP) in Brazil in 1998 to that in 2000?
Give a very brief answer. 1.03. What is the ratio of the Value added (% of GDP) in Congo (Democratic) in 1998 to that in 2000?
Your response must be concise. 0.7. What is the ratio of the Value added (% of GDP) in Papua New Guinea in 1998 to that in 2000?
Your answer should be compact. 1.38. What is the ratio of the Value added (% of GDP) of United Kingdom in 1998 to that in 2000?
Provide a short and direct response. 0.99. What is the ratio of the Value added (% of GDP) of Brazil in 1998 to that in 2001?
Provide a short and direct response. 1.03. What is the ratio of the Value added (% of GDP) in Congo (Democratic) in 1998 to that in 2001?
Provide a succinct answer. 0.89. What is the ratio of the Value added (% of GDP) of Papua New Guinea in 1998 to that in 2001?
Your response must be concise. 1.36. What is the ratio of the Value added (% of GDP) in United Kingdom in 1998 to that in 2001?
Ensure brevity in your answer.  0.97. What is the ratio of the Value added (% of GDP) of Brazil in 1998 to that in 2002?
Ensure brevity in your answer.  1.04. What is the ratio of the Value added (% of GDP) of Congo (Democratic) in 1998 to that in 2002?
Your response must be concise. 0.81. What is the ratio of the Value added (% of GDP) in Papua New Guinea in 1998 to that in 2002?
Provide a succinct answer. 1.35. What is the ratio of the Value added (% of GDP) in United Kingdom in 1998 to that in 2002?
Offer a very short reply. 0.96. What is the ratio of the Value added (% of GDP) in Brazil in 1998 to that in 2003?
Ensure brevity in your answer.  1.06. What is the ratio of the Value added (% of GDP) of Congo (Democratic) in 1998 to that in 2003?
Provide a succinct answer. 0.73. What is the ratio of the Value added (% of GDP) in Papua New Guinea in 1998 to that in 2003?
Keep it short and to the point. 1.36. What is the ratio of the Value added (% of GDP) in United Kingdom in 1998 to that in 2003?
Provide a short and direct response. 0.95. What is the ratio of the Value added (% of GDP) of Brazil in 1998 to that in 2004?
Provide a short and direct response. 1.08. What is the ratio of the Value added (% of GDP) of Congo (Democratic) in 1998 to that in 2004?
Provide a succinct answer. 0.75. What is the ratio of the Value added (% of GDP) of Papua New Guinea in 1998 to that in 2004?
Keep it short and to the point. 1.35. What is the ratio of the Value added (% of GDP) in United Kingdom in 1998 to that in 2004?
Give a very brief answer. 0.94. What is the ratio of the Value added (% of GDP) of Brazil in 1999 to that in 2000?
Provide a short and direct response. 1.03. What is the ratio of the Value added (% of GDP) of Congo (Democratic) in 1999 to that in 2000?
Ensure brevity in your answer.  0.63. What is the ratio of the Value added (% of GDP) in Papua New Guinea in 1999 to that in 2000?
Offer a terse response. 1.18. What is the ratio of the Value added (% of GDP) of United Kingdom in 1999 to that in 2000?
Provide a succinct answer. 1. What is the ratio of the Value added (% of GDP) of Brazil in 1999 to that in 2001?
Make the answer very short. 1.03. What is the ratio of the Value added (% of GDP) in Congo (Democratic) in 1999 to that in 2001?
Your answer should be very brief. 0.8. What is the ratio of the Value added (% of GDP) in Papua New Guinea in 1999 to that in 2001?
Make the answer very short. 1.16. What is the ratio of the Value added (% of GDP) of United Kingdom in 1999 to that in 2001?
Give a very brief answer. 0.98. What is the ratio of the Value added (% of GDP) of Congo (Democratic) in 1999 to that in 2002?
Provide a succinct answer. 0.73. What is the ratio of the Value added (% of GDP) in Papua New Guinea in 1999 to that in 2002?
Keep it short and to the point. 1.15. What is the ratio of the Value added (% of GDP) in United Kingdom in 1999 to that in 2002?
Provide a succinct answer. 0.98. What is the ratio of the Value added (% of GDP) of Brazil in 1999 to that in 2003?
Keep it short and to the point. 1.06. What is the ratio of the Value added (% of GDP) in Congo (Democratic) in 1999 to that in 2003?
Keep it short and to the point. 0.66. What is the ratio of the Value added (% of GDP) of Papua New Guinea in 1999 to that in 2003?
Your answer should be very brief. 1.16. What is the ratio of the Value added (% of GDP) of United Kingdom in 1999 to that in 2003?
Your response must be concise. 0.96. What is the ratio of the Value added (% of GDP) of Brazil in 1999 to that in 2004?
Keep it short and to the point. 1.08. What is the ratio of the Value added (% of GDP) of Congo (Democratic) in 1999 to that in 2004?
Offer a terse response. 0.68. What is the ratio of the Value added (% of GDP) of Papua New Guinea in 1999 to that in 2004?
Ensure brevity in your answer.  1.15. What is the ratio of the Value added (% of GDP) of United Kingdom in 1999 to that in 2004?
Give a very brief answer. 0.95. What is the ratio of the Value added (% of GDP) of Congo (Democratic) in 2000 to that in 2001?
Ensure brevity in your answer.  1.27. What is the ratio of the Value added (% of GDP) of Papua New Guinea in 2000 to that in 2001?
Make the answer very short. 0.98. What is the ratio of the Value added (% of GDP) of United Kingdom in 2000 to that in 2001?
Your answer should be very brief. 0.98. What is the ratio of the Value added (% of GDP) in Brazil in 2000 to that in 2002?
Make the answer very short. 1.01. What is the ratio of the Value added (% of GDP) in Congo (Democratic) in 2000 to that in 2002?
Keep it short and to the point. 1.15. What is the ratio of the Value added (% of GDP) of Papua New Guinea in 2000 to that in 2002?
Provide a succinct answer. 0.98. What is the ratio of the Value added (% of GDP) in United Kingdom in 2000 to that in 2002?
Ensure brevity in your answer.  0.97. What is the ratio of the Value added (% of GDP) of Brazil in 2000 to that in 2003?
Offer a terse response. 1.03. What is the ratio of the Value added (% of GDP) in Congo (Democratic) in 2000 to that in 2003?
Provide a succinct answer. 1.04. What is the ratio of the Value added (% of GDP) of Papua New Guinea in 2000 to that in 2003?
Offer a terse response. 0.99. What is the ratio of the Value added (% of GDP) in United Kingdom in 2000 to that in 2003?
Your answer should be compact. 0.96. What is the ratio of the Value added (% of GDP) of Brazil in 2000 to that in 2004?
Keep it short and to the point. 1.05. What is the ratio of the Value added (% of GDP) of Congo (Democratic) in 2000 to that in 2004?
Provide a short and direct response. 1.07. What is the ratio of the Value added (% of GDP) of Papua New Guinea in 2000 to that in 2004?
Your answer should be very brief. 0.98. What is the ratio of the Value added (% of GDP) of United Kingdom in 2000 to that in 2004?
Your answer should be compact. 0.95. What is the ratio of the Value added (% of GDP) of Brazil in 2001 to that in 2002?
Give a very brief answer. 1.01. What is the ratio of the Value added (% of GDP) of Congo (Democratic) in 2001 to that in 2002?
Give a very brief answer. 0.91. What is the ratio of the Value added (% of GDP) in Papua New Guinea in 2001 to that in 2002?
Offer a terse response. 0.99. What is the ratio of the Value added (% of GDP) in United Kingdom in 2001 to that in 2002?
Offer a terse response. 0.99. What is the ratio of the Value added (% of GDP) of Brazil in 2001 to that in 2003?
Offer a terse response. 1.03. What is the ratio of the Value added (% of GDP) of Congo (Democratic) in 2001 to that in 2003?
Make the answer very short. 0.82. What is the ratio of the Value added (% of GDP) of Papua New Guinea in 2001 to that in 2003?
Keep it short and to the point. 1. What is the ratio of the Value added (% of GDP) of United Kingdom in 2001 to that in 2003?
Your answer should be very brief. 0.98. What is the ratio of the Value added (% of GDP) in Brazil in 2001 to that in 2004?
Provide a succinct answer. 1.05. What is the ratio of the Value added (% of GDP) of Congo (Democratic) in 2001 to that in 2004?
Ensure brevity in your answer.  0.85. What is the ratio of the Value added (% of GDP) in Papua New Guinea in 2001 to that in 2004?
Offer a terse response. 0.99. What is the ratio of the Value added (% of GDP) in United Kingdom in 2001 to that in 2004?
Ensure brevity in your answer.  0.97. What is the ratio of the Value added (% of GDP) in Brazil in 2002 to that in 2003?
Your answer should be compact. 1.02. What is the ratio of the Value added (% of GDP) in Congo (Democratic) in 2002 to that in 2003?
Your response must be concise. 0.9. What is the ratio of the Value added (% of GDP) in Papua New Guinea in 2002 to that in 2003?
Provide a succinct answer. 1.01. What is the ratio of the Value added (% of GDP) of United Kingdom in 2002 to that in 2003?
Your answer should be compact. 0.99. What is the ratio of the Value added (% of GDP) in Brazil in 2002 to that in 2004?
Your answer should be very brief. 1.04. What is the ratio of the Value added (% of GDP) in Congo (Democratic) in 2002 to that in 2004?
Your answer should be compact. 0.93. What is the ratio of the Value added (% of GDP) in Papua New Guinea in 2002 to that in 2004?
Your response must be concise. 1. What is the ratio of the Value added (% of GDP) of United Kingdom in 2002 to that in 2004?
Keep it short and to the point. 0.97. What is the ratio of the Value added (% of GDP) of Brazil in 2003 to that in 2004?
Ensure brevity in your answer.  1.02. What is the ratio of the Value added (% of GDP) of Congo (Democratic) in 2003 to that in 2004?
Your answer should be compact. 1.03. What is the ratio of the Value added (% of GDP) in Papua New Guinea in 2003 to that in 2004?
Offer a very short reply. 0.99. What is the difference between the highest and the second highest Value added (% of GDP) of Brazil?
Make the answer very short. 0.08. What is the difference between the highest and the second highest Value added (% of GDP) in Congo (Democratic)?
Provide a short and direct response. 1.68. What is the difference between the highest and the second highest Value added (% of GDP) in Papua New Guinea?
Your answer should be very brief. 4.68. What is the difference between the highest and the second highest Value added (% of GDP) in United Kingdom?
Offer a terse response. 0.92. What is the difference between the highest and the lowest Value added (% of GDP) of Brazil?
Make the answer very short. 5.22. What is the difference between the highest and the lowest Value added (% of GDP) in Congo (Democratic)?
Your answer should be compact. 16.54. What is the difference between the highest and the lowest Value added (% of GDP) in Papua New Guinea?
Your answer should be compact. 8.7. What is the difference between the highest and the lowest Value added (% of GDP) of United Kingdom?
Provide a short and direct response. 4.9. 